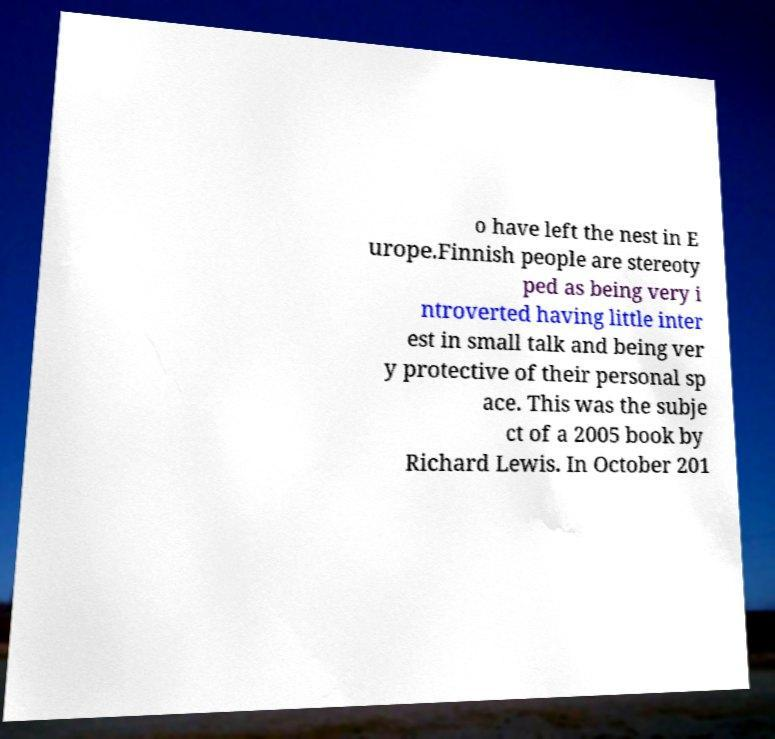Please read and relay the text visible in this image. What does it say? o have left the nest in E urope.Finnish people are stereoty ped as being very i ntroverted having little inter est in small talk and being ver y protective of their personal sp ace. This was the subje ct of a 2005 book by Richard Lewis. In October 201 